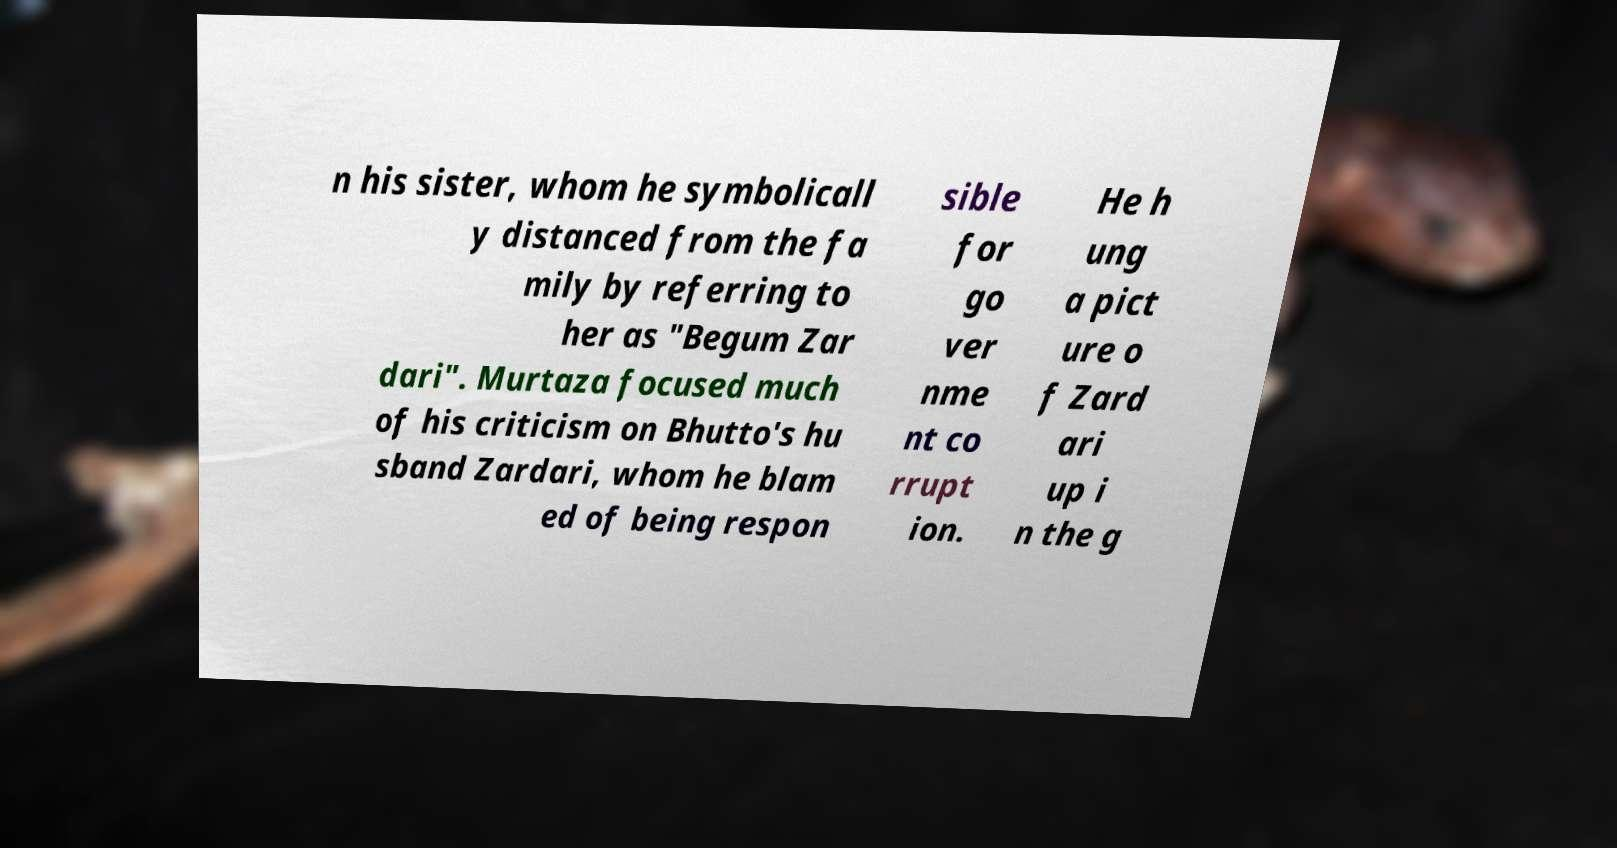Please read and relay the text visible in this image. What does it say? n his sister, whom he symbolicall y distanced from the fa mily by referring to her as "Begum Zar dari". Murtaza focused much of his criticism on Bhutto's hu sband Zardari, whom he blam ed of being respon sible for go ver nme nt co rrupt ion. He h ung a pict ure o f Zard ari up i n the g 